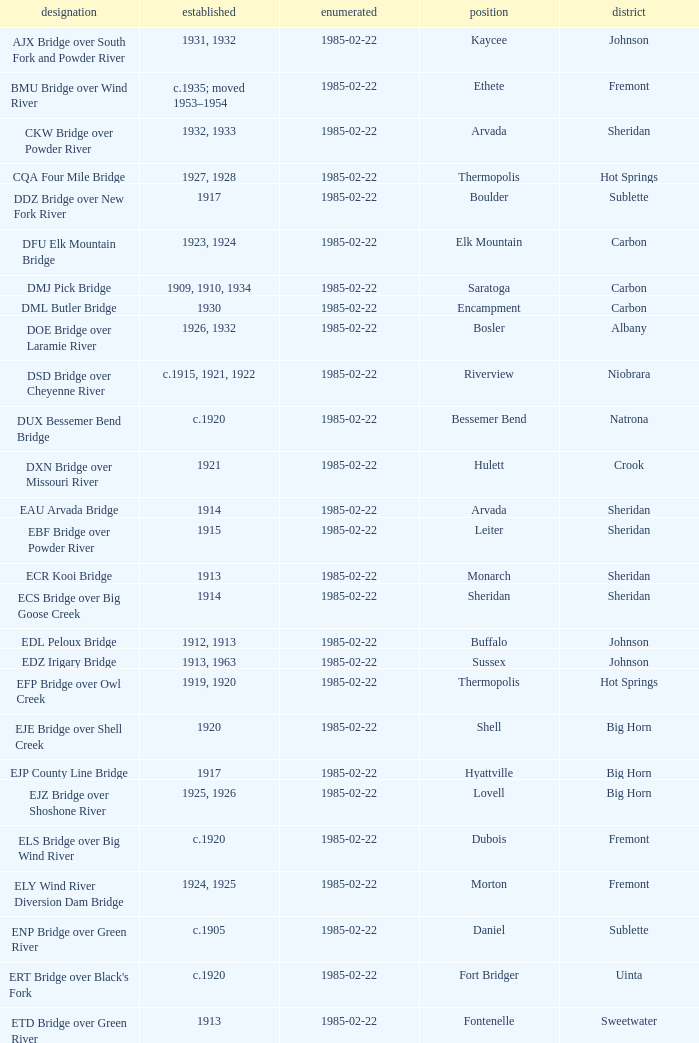In boulder, which county is the bridge located in? Sublette. 